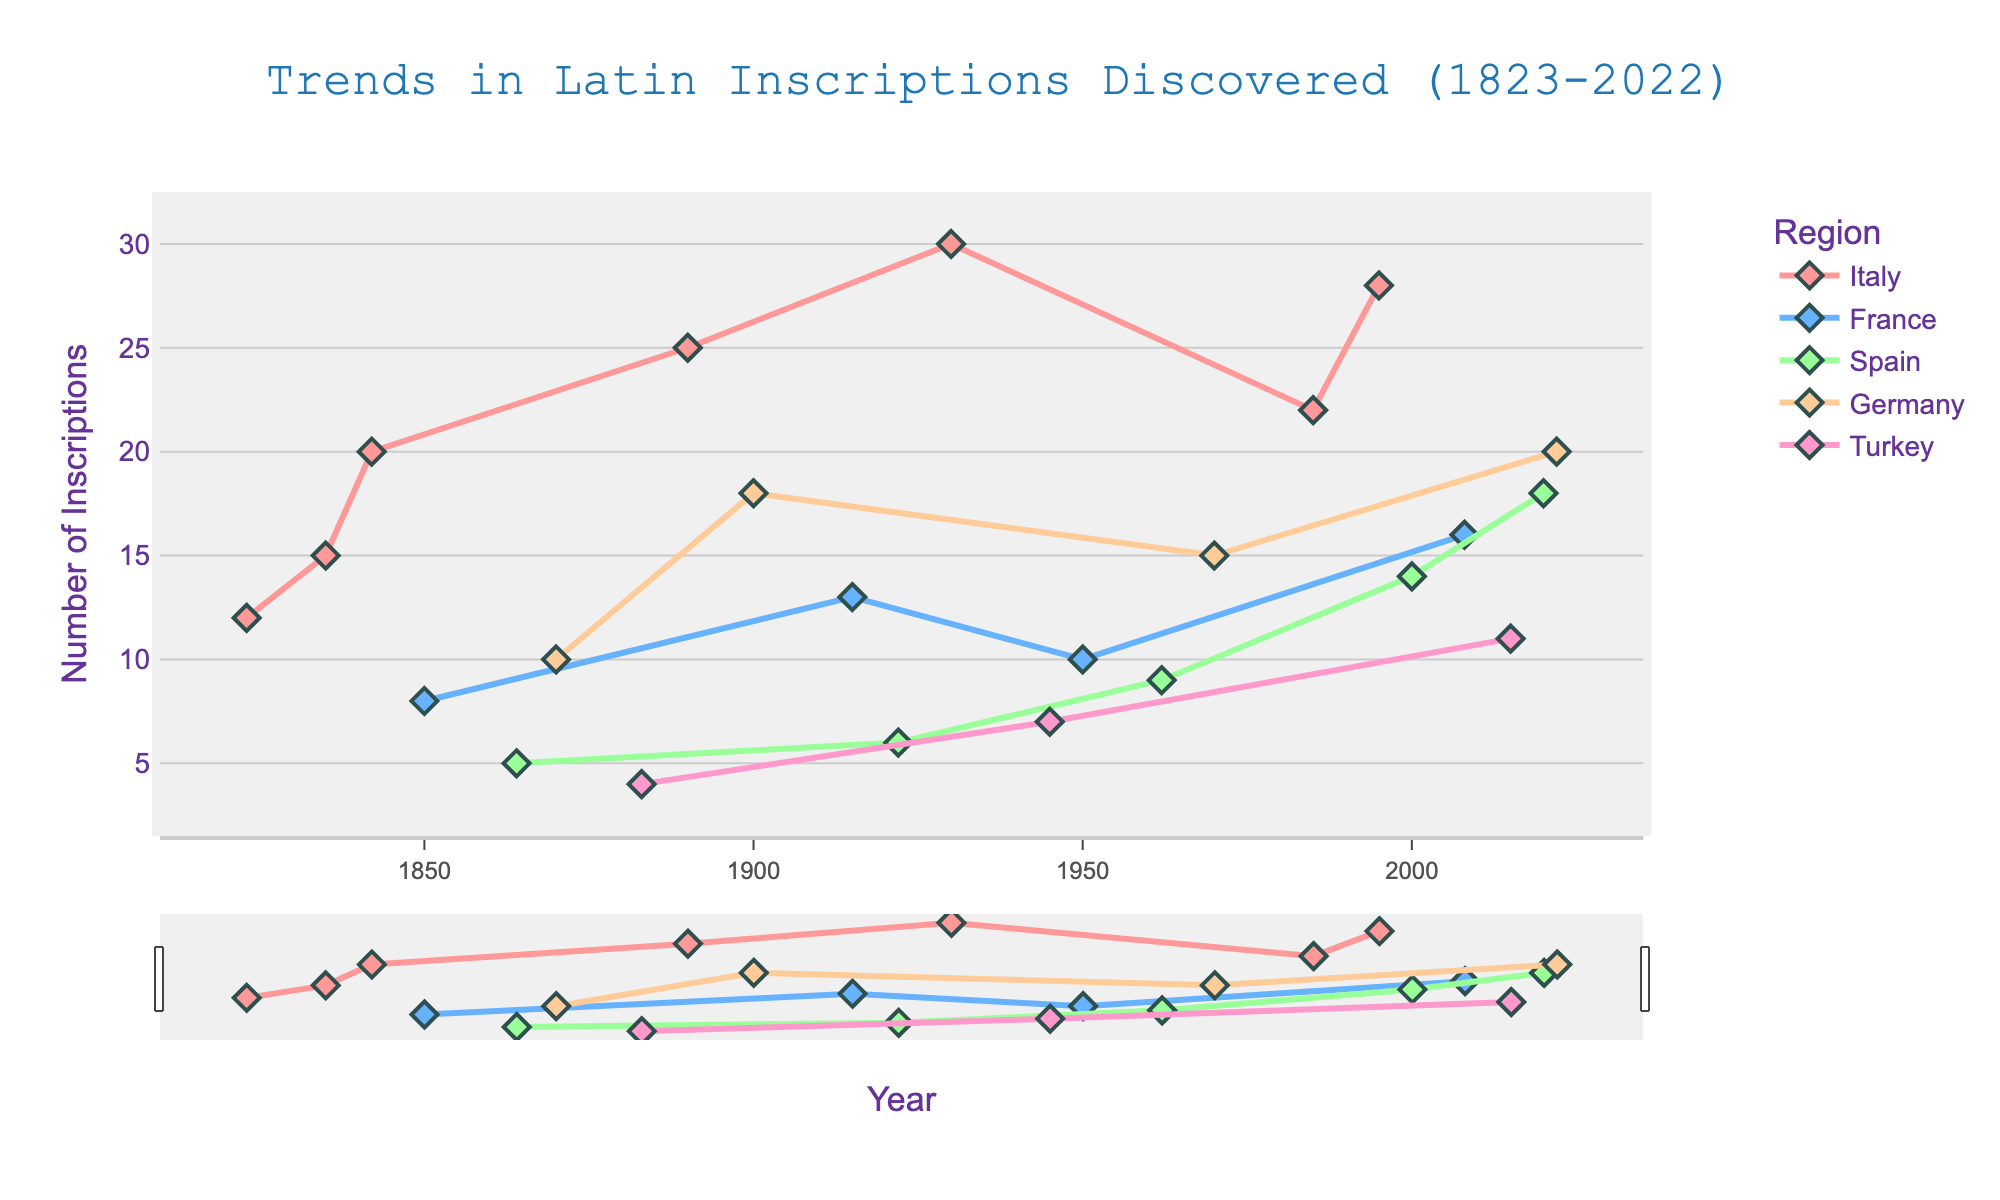What is the title of the plot? The title is found at the top, centered and in larger font size. It reads "Trends in Latin Inscriptions Discovered (1823-2022)".
Answer: Trends in Latin Inscriptions Discovered (1823-2022) Which region had the highest number of inscriptions discovered in 1930? By locating the year 1930 on the x-axis and looking at the highest point among the lines, Italy emerges as the region with 30 inscriptions.
Answer: Italy How many inscriptions were discovered in Spain in 2020? By following the line or marker for Spain at the year 2020, it shows 18 inscriptions.
Answer: 18 What was the trend for Italy from 1835 to 1930? Plotting the changes in inscriptions discovered in Italy between these years shows an initial increase from 12 in 1823 to 30 in 1930.
Answer: Increasing trend Compare the number of inscriptions discovered in France in 2008 and Turkey in 2015. Which year had more discoveries? France had 16 inscriptions in 2008, while Turkey had 11 in 2015. This can be confirmed by tracing the respective lines to those years.
Answer: France in 2008 Which region had the most diverse number of discoveries over the represented years? Analyzing the overall fluctuation in the respective lines shows that Italy showed the most varied discoveries over the years.
Answer: Italy How many total inscriptions were discovered in Turkey over the entire time period? By summing up the values for each recorded year in Turkey: 4 (1883) + 7 (1945) + 11 (2015) = 22
Answer: 22 Describe the trend for the region of France between 1915 and 2008. The number of discoveries changed from 13 in 1915, dropped to 10 in 1950, and then increased to 16 by 2008, indicating a fluctuating but overall increasing trend.
Answer: Fluctuating with an increasing overall trend In which decade did Germany see the highest number of discoveries? Observing the peaks of the line or markers for Germany shows that the highest number registered was in 2022 with 20 discoveries.
Answer: 2022 Between 1995 and 2020, which region had the most consistent discovery rate and what was the number of inscriptions during that period? Comparing the stability of the lines over these years shows that Germany had a relatively steady number of discoveries, increasing from 15 in 1970 to 20 in 2022.
Answer: Germany with rates increasing consistently 